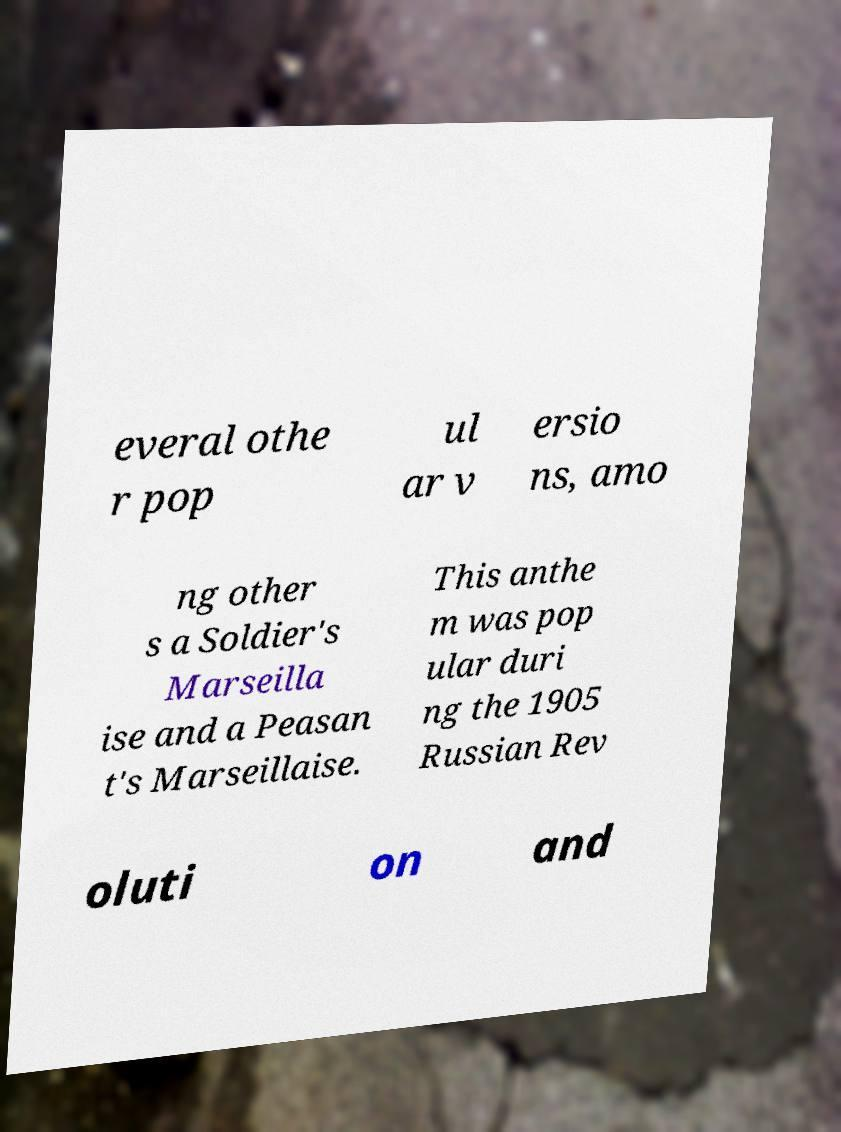Can you accurately transcribe the text from the provided image for me? everal othe r pop ul ar v ersio ns, amo ng other s a Soldier's Marseilla ise and a Peasan t's Marseillaise. This anthe m was pop ular duri ng the 1905 Russian Rev oluti on and 